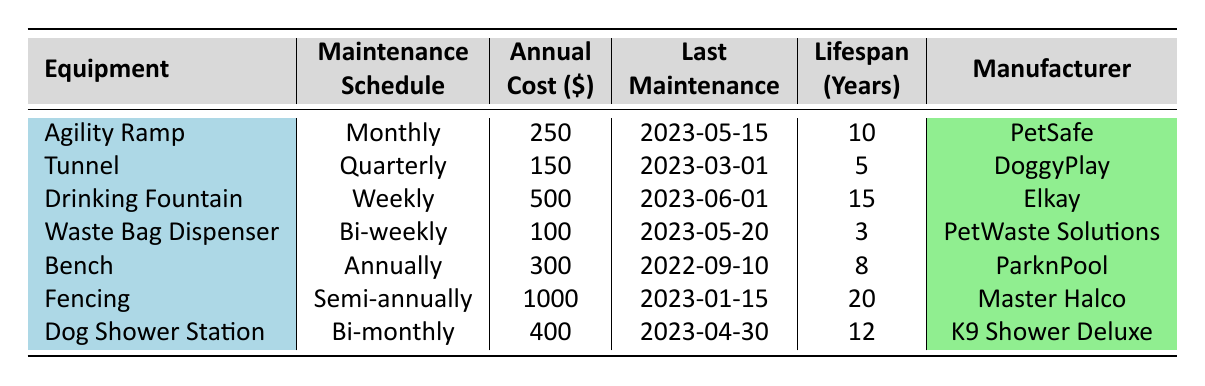What is the maintenance schedule for the Drinking Fountain? The table shows that the Drinking Fountain has a maintenance schedule of Weekly.
Answer: Weekly Which equipment has the highest annual maintenance cost? By comparing the annual costs, the Fencing has the highest cost at $1000.
Answer: Fencing How often is the Waste Bag Dispenser maintained? The table indicates that the Waste Bag Dispenser is maintained Bi-weekly.
Answer: Bi-weekly What is the total annual cost of maintaining all dog park equipment? The annual costs are $250 + $150 + $500 + $100 + $300 + $1000 + $400 = $2700.
Answer: $2700 Is the Lifespan of the Tunnel longer than that of the Waste Bag Dispenser? The Lifespan of the Tunnel is 5 years and for the Waste Bag Dispenser it is 3 years, so yes, the Tunnel has a longer lifespan.
Answer: Yes When was the last maintenance for the Agility Ramp? According to the table, the last maintenance for the Agility Ramp was on 2023-05-15.
Answer: 2023-05-15 What is the average lifespan of all the equipment? The lifespans are 10, 5, 15, 3, 8, 20, 12. The average is calculated as (10 + 5 + 15 + 3 + 8 + 20 + 12) / 7 = 10.14 years.
Answer: 10.14 years Which equipment is maintained the most frequently? The most frequent schedule is Weekly, which applies to the Drinking Fountain.
Answer: Drinking Fountain Was the Bench maintained more recently than the Fencing? The last maintenance for the Bench was on 2022-09-10 and for the Fencing it was on 2023-01-15. Since 2023 is later than 2022, Fencing was maintained more recently.
Answer: No How much would it cost to maintain the Tunnel for its entire lifespan? The Tunnel has a lifespan of 5 years and an annual cost of $150, so the total cost is 5 * $150 = $750.
Answer: $750 Is the Manufacturer of the Dog Shower Station different from the Manufacturer of the Drinking Fountain? The Dog Shower Station is manufactured by K9 Shower Deluxe and the Drinking Fountain is manufactured by Elkay, which are different.
Answer: Yes 